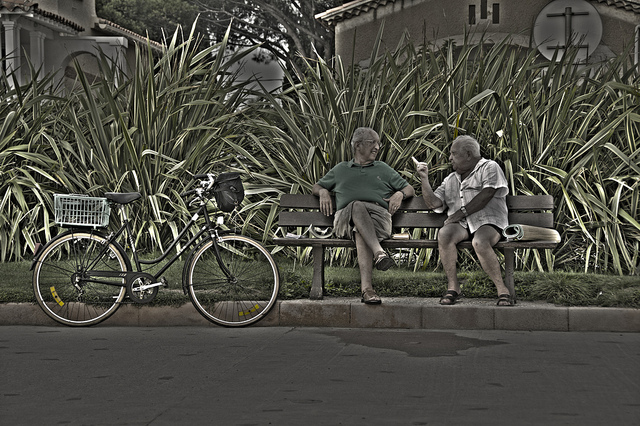<image>What is the pattern type on the bench called? I don't know what the pattern type on the bench is called. It can be solid, slat, wood, or wooden slats. What is the pattern type on the bench called? I don't know what the pattern type on the bench is called. It can be 'solid', 'slat', 'wood', 'wooden slats', 'none', 'slatted', or 'normal'. 